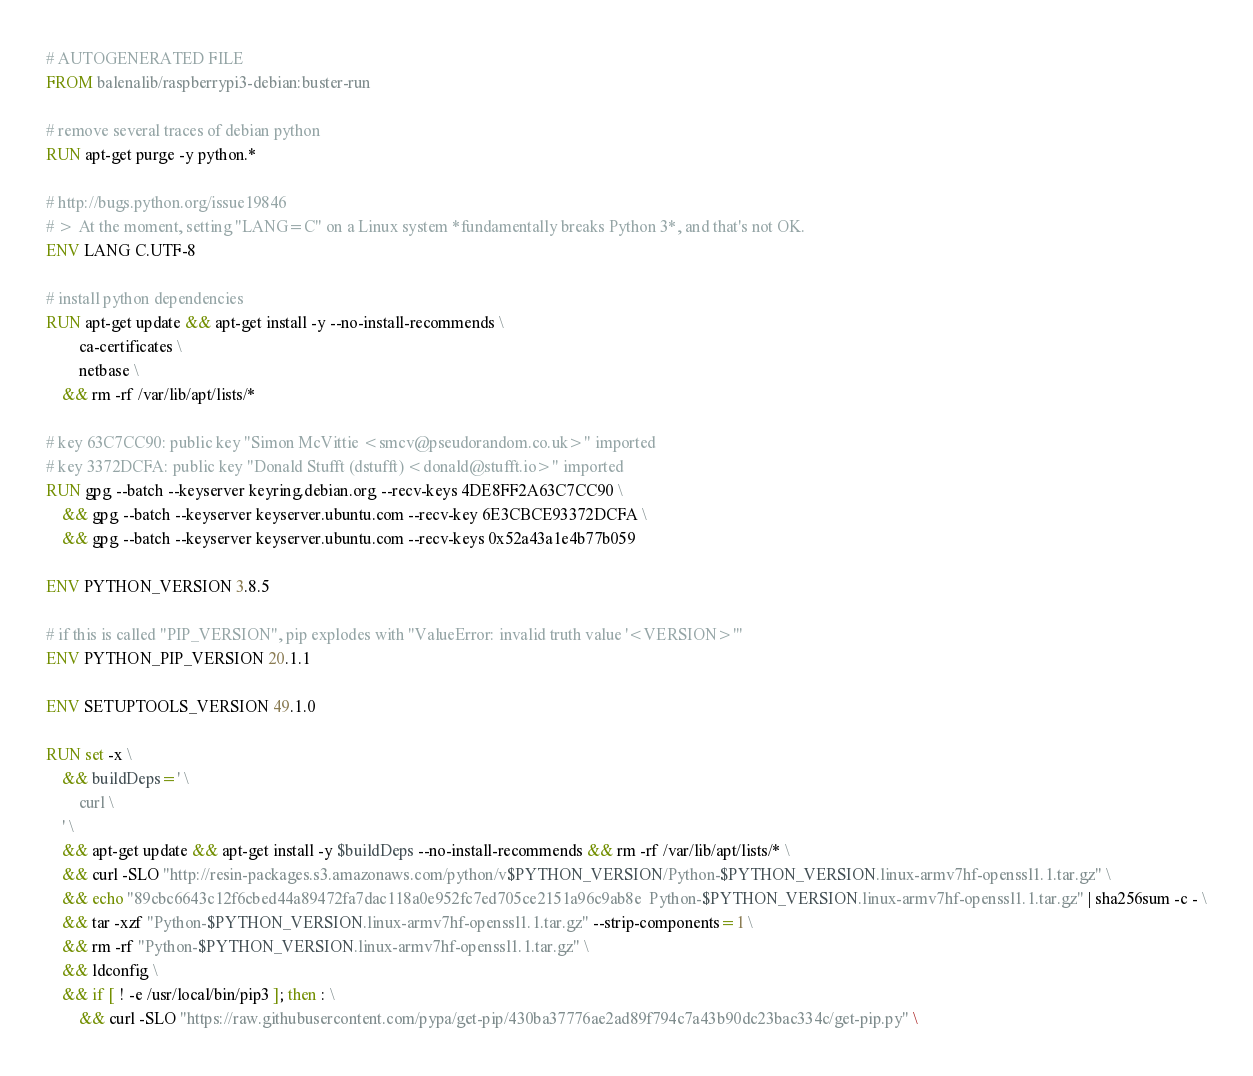<code> <loc_0><loc_0><loc_500><loc_500><_Dockerfile_># AUTOGENERATED FILE
FROM balenalib/raspberrypi3-debian:buster-run

# remove several traces of debian python
RUN apt-get purge -y python.*

# http://bugs.python.org/issue19846
# > At the moment, setting "LANG=C" on a Linux system *fundamentally breaks Python 3*, and that's not OK.
ENV LANG C.UTF-8

# install python dependencies
RUN apt-get update && apt-get install -y --no-install-recommends \
		ca-certificates \
		netbase \
	&& rm -rf /var/lib/apt/lists/*

# key 63C7CC90: public key "Simon McVittie <smcv@pseudorandom.co.uk>" imported
# key 3372DCFA: public key "Donald Stufft (dstufft) <donald@stufft.io>" imported
RUN gpg --batch --keyserver keyring.debian.org --recv-keys 4DE8FF2A63C7CC90 \
	&& gpg --batch --keyserver keyserver.ubuntu.com --recv-key 6E3CBCE93372DCFA \
	&& gpg --batch --keyserver keyserver.ubuntu.com --recv-keys 0x52a43a1e4b77b059

ENV PYTHON_VERSION 3.8.5

# if this is called "PIP_VERSION", pip explodes with "ValueError: invalid truth value '<VERSION>'"
ENV PYTHON_PIP_VERSION 20.1.1

ENV SETUPTOOLS_VERSION 49.1.0

RUN set -x \
	&& buildDeps=' \
		curl \
	' \
	&& apt-get update && apt-get install -y $buildDeps --no-install-recommends && rm -rf /var/lib/apt/lists/* \
	&& curl -SLO "http://resin-packages.s3.amazonaws.com/python/v$PYTHON_VERSION/Python-$PYTHON_VERSION.linux-armv7hf-openssl1.1.tar.gz" \
	&& echo "89cbc6643c12f6cbed44a89472fa7dac118a0e952fc7ed705ce2151a96c9ab8e  Python-$PYTHON_VERSION.linux-armv7hf-openssl1.1.tar.gz" | sha256sum -c - \
	&& tar -xzf "Python-$PYTHON_VERSION.linux-armv7hf-openssl1.1.tar.gz" --strip-components=1 \
	&& rm -rf "Python-$PYTHON_VERSION.linux-armv7hf-openssl1.1.tar.gz" \
	&& ldconfig \
	&& if [ ! -e /usr/local/bin/pip3 ]; then : \
		&& curl -SLO "https://raw.githubusercontent.com/pypa/get-pip/430ba37776ae2ad89f794c7a43b90dc23bac334c/get-pip.py" \</code> 